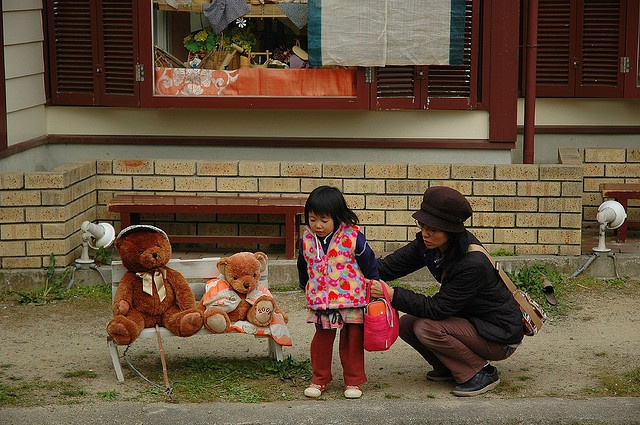Describe the objects in this image and their specific colors. I can see people in black, maroon, and gray tones, people in black, maroon, brown, and lightpink tones, bench in black, maroon, brown, and gray tones, teddy bear in black, maroon, and brown tones, and teddy bear in black, brown, gray, maroon, and darkgray tones in this image. 